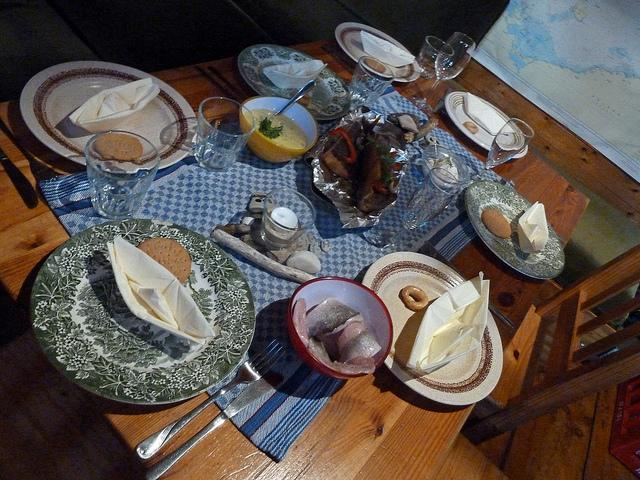What are the napkins folded to look like? boats 